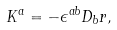<formula> <loc_0><loc_0><loc_500><loc_500>K ^ { a } = - \epsilon ^ { a b } D _ { b } r ,</formula> 